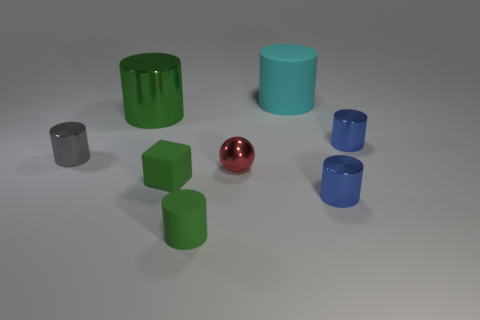Are there any other things that have the same shape as the tiny red object?
Provide a short and direct response. No. Is the size of the metal thing in front of the ball the same as the green cylinder that is behind the gray metallic object?
Provide a short and direct response. No. Is the number of green shiny cylinders less than the number of big yellow matte spheres?
Offer a very short reply. No. What number of metallic things are yellow spheres or large things?
Your response must be concise. 1. Are there any small blue shiny cylinders that are in front of the small rubber cube right of the small gray cylinder?
Keep it short and to the point. Yes. Is the material of the large cylinder left of the small green matte cylinder the same as the small green cylinder?
Your response must be concise. No. What number of other things are there of the same color as the small rubber cube?
Provide a short and direct response. 2. Is the tiny matte cylinder the same color as the tiny block?
Your answer should be very brief. Yes. There is a cylinder behind the big object that is on the left side of the large cyan matte cylinder; how big is it?
Provide a short and direct response. Large. Is the big object in front of the large cyan matte cylinder made of the same material as the small thing that is to the left of the block?
Give a very brief answer. Yes. 